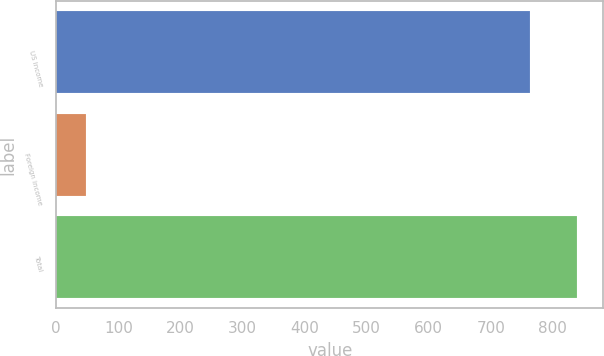Convert chart to OTSL. <chart><loc_0><loc_0><loc_500><loc_500><bar_chart><fcel>US income<fcel>Foreign income<fcel>Total<nl><fcel>763<fcel>48<fcel>839.3<nl></chart> 